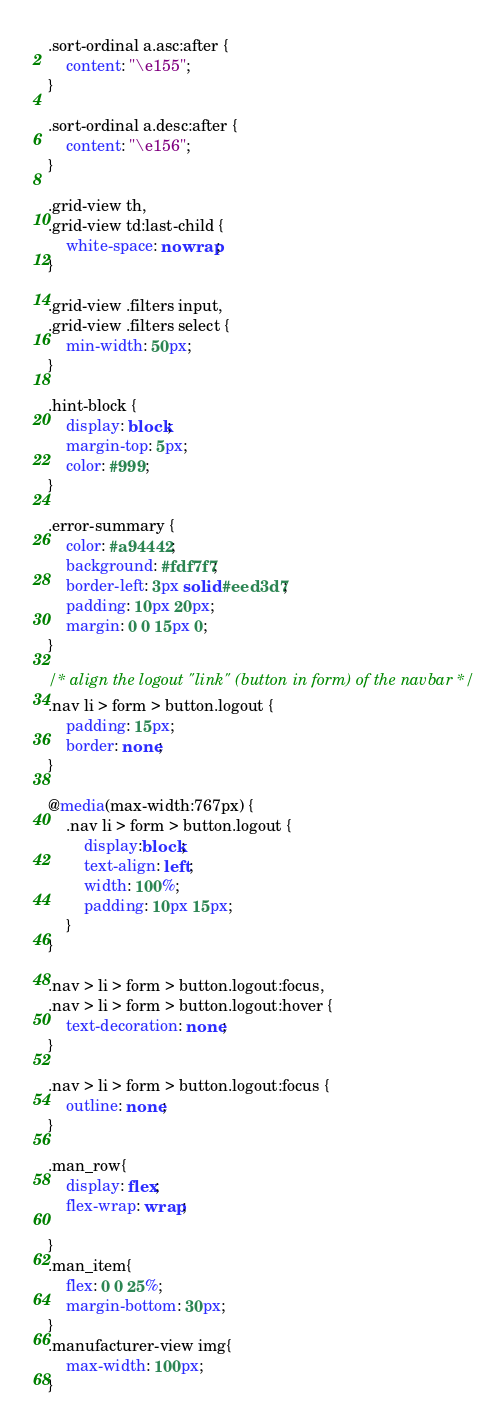<code> <loc_0><loc_0><loc_500><loc_500><_CSS_>
.sort-ordinal a.asc:after {
    content: "\e155";
}

.sort-ordinal a.desc:after {
    content: "\e156";
}

.grid-view th,
.grid-view td:last-child {
    white-space: nowrap;
}

.grid-view .filters input,
.grid-view .filters select {
    min-width: 50px;
}

.hint-block {
    display: block;
    margin-top: 5px;
    color: #999;
}

.error-summary {
    color: #a94442;
    background: #fdf7f7;
    border-left: 3px solid #eed3d7;
    padding: 10px 20px;
    margin: 0 0 15px 0;
}

/* align the logout "link" (button in form) of the navbar */
.nav li > form > button.logout {
    padding: 15px;
    border: none;
}

@media(max-width:767px) {
    .nav li > form > button.logout {
        display:block;
        text-align: left;
        width: 100%;
        padding: 10px 15px;
    }
}

.nav > li > form > button.logout:focus,
.nav > li > form > button.logout:hover {
    text-decoration: none;
}

.nav > li > form > button.logout:focus {
    outline: none;
}

.man_row{
    display: flex;
    flex-wrap: wrap;

}
.man_item{
    flex: 0 0 25%;
    margin-bottom: 30px;
}
.manufacturer-view img{
    max-width: 100px;
}
</code> 